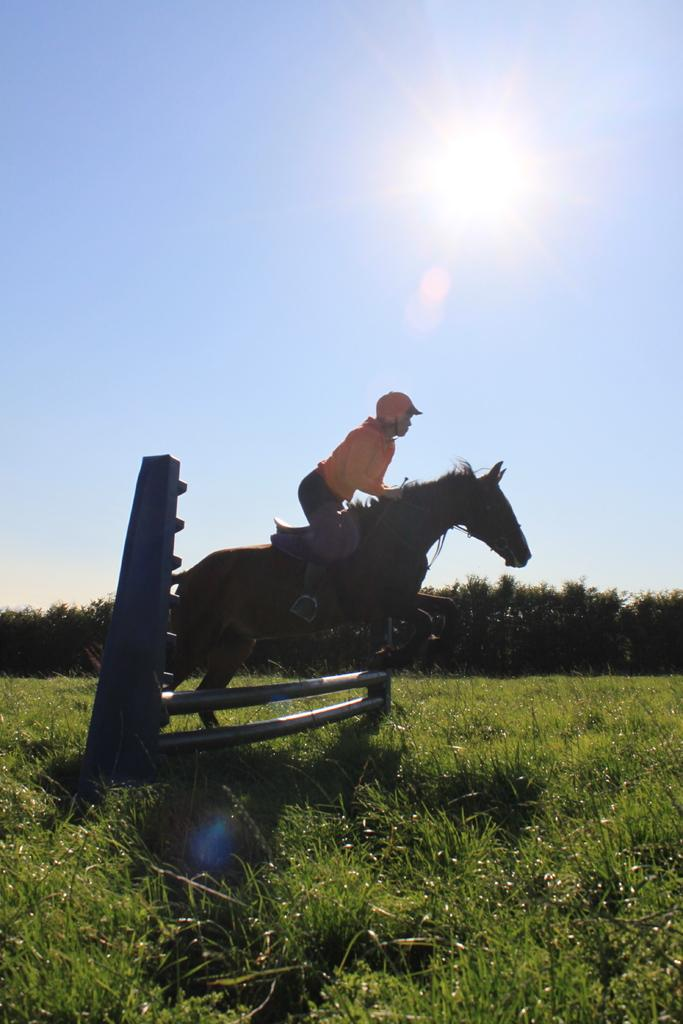What activity is the person in the image engaged in? The person is riding a horse in the image. What color is the person's t-shirt? The person is wearing a yellow t-shirt. What type of headwear is the person wearing? The person is wearing a cap. What can be seen in the background of the image? There are trees and the sky visible in the background of the image. What type of terrain is visible in the image? There is grass in the image. How many nails are used to hold the passenger in place on the horse? There is no passenger mentioned in the image, and the person riding the horse is not held in place by nails. 